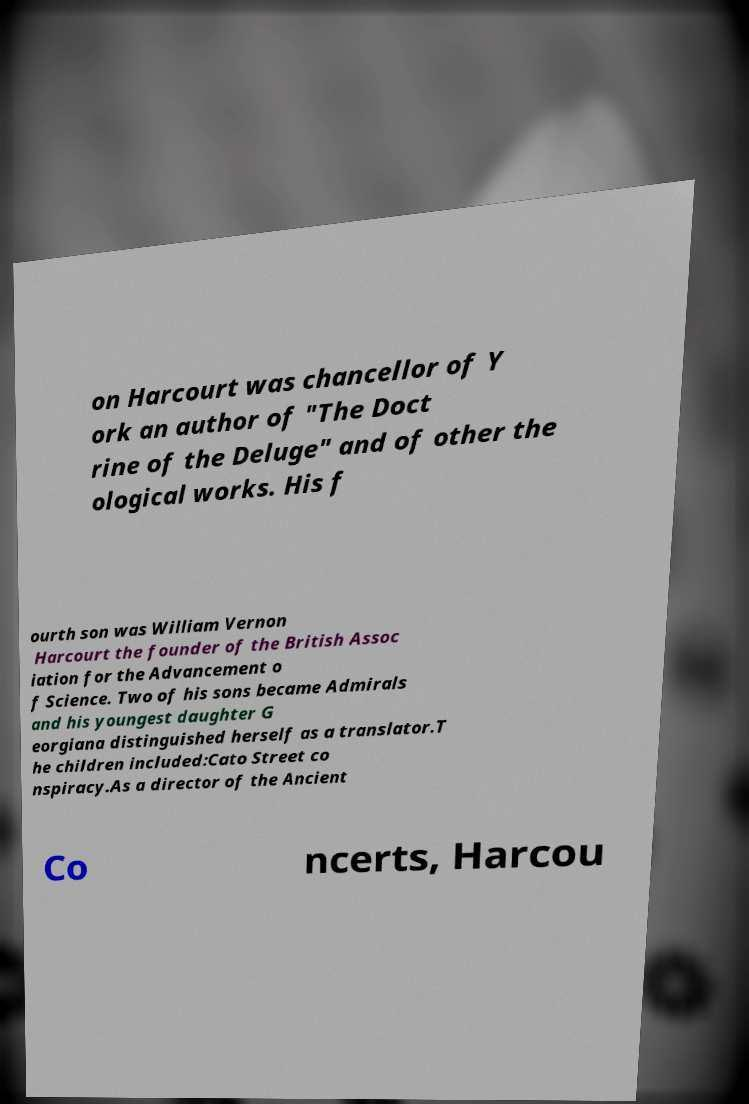Could you assist in decoding the text presented in this image and type it out clearly? on Harcourt was chancellor of Y ork an author of "The Doct rine of the Deluge" and of other the ological works. His f ourth son was William Vernon Harcourt the founder of the British Assoc iation for the Advancement o f Science. Two of his sons became Admirals and his youngest daughter G eorgiana distinguished herself as a translator.T he children included:Cato Street co nspiracy.As a director of the Ancient Co ncerts, Harcou 